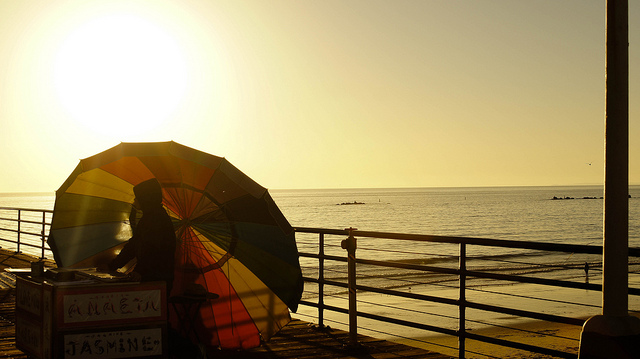<image>What is the man holding? I am not sure what the man is holding. It could be an umbrella or a hot dog. What is the man holding? I don't know what the man is holding. It can be seen an umbrella, a beach umbrella, a hot dog or a cart. 